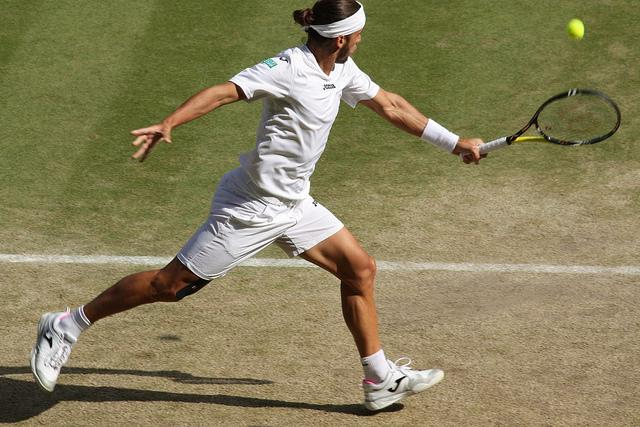What is in the man's hand? racket 